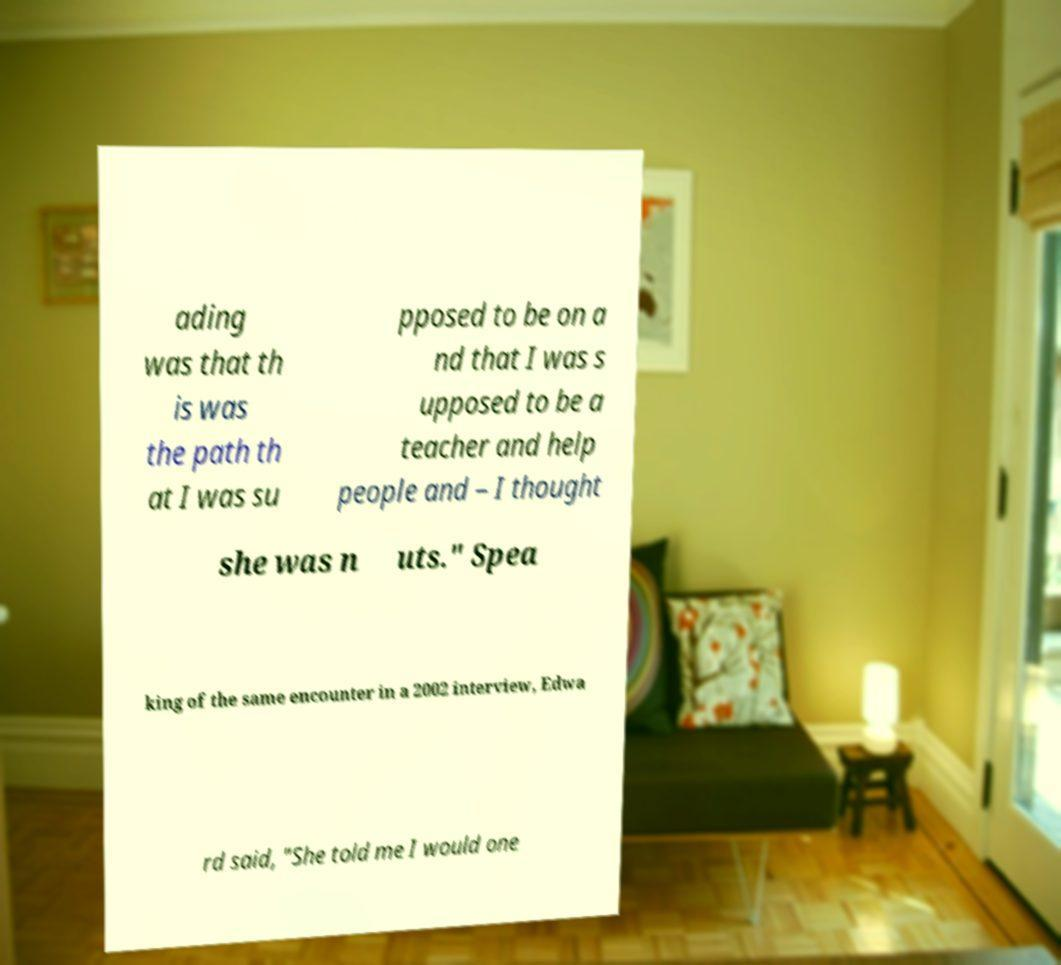Could you extract and type out the text from this image? ading was that th is was the path th at I was su pposed to be on a nd that I was s upposed to be a teacher and help people and – I thought she was n uts." Spea king of the same encounter in a 2002 interview, Edwa rd said, "She told me I would one 